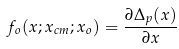Convert formula to latex. <formula><loc_0><loc_0><loc_500><loc_500>f _ { o } ( x ; x _ { c m } ; x _ { o } ) = \frac { \partial \Delta _ { p } ( x ) } { \partial x }</formula> 